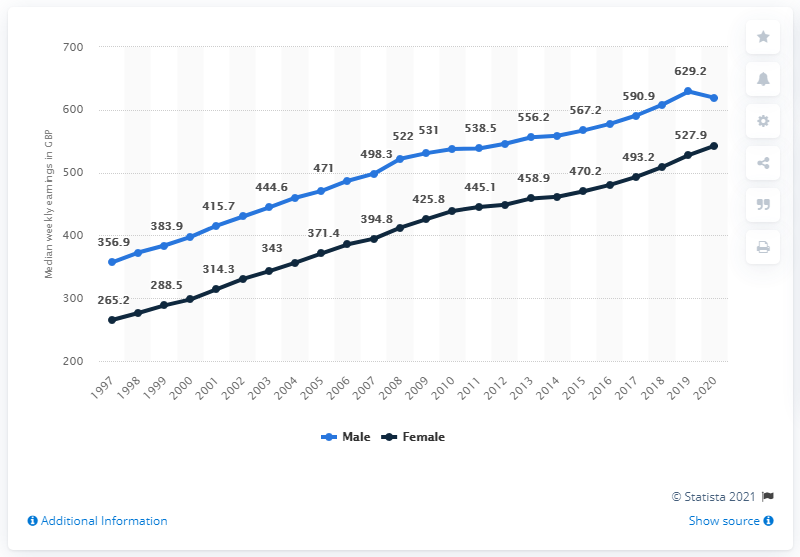Highlight a few significant elements in this photo. The highest weekly earnings for a male is 629.2. The highest earnings of men are significantly higher than the lowest earnings of men, with a difference of 272.3%. 